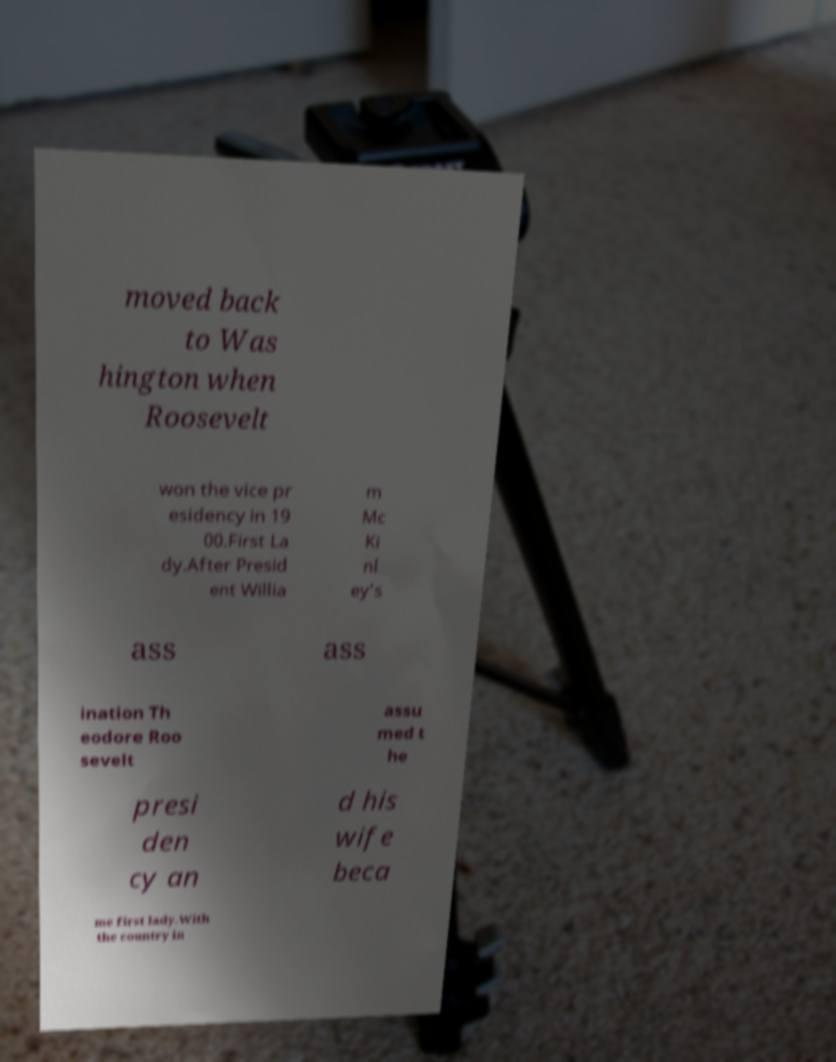Could you assist in decoding the text presented in this image and type it out clearly? moved back to Was hington when Roosevelt won the vice pr esidency in 19 00.First La dy.After Presid ent Willia m Mc Ki nl ey’s ass ass ination Th eodore Roo sevelt assu med t he presi den cy an d his wife beca me first lady.With the country in 